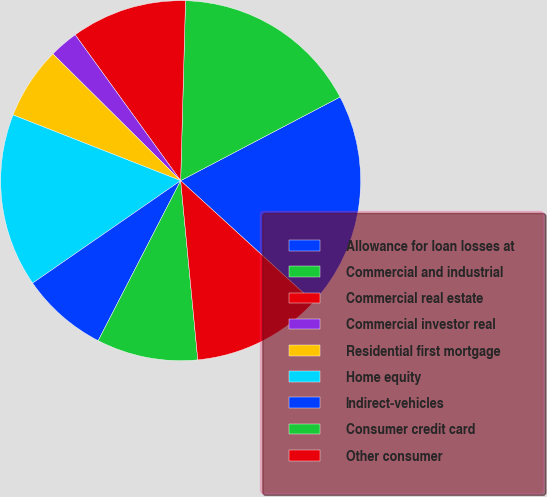Convert chart to OTSL. <chart><loc_0><loc_0><loc_500><loc_500><pie_chart><fcel>Allowance for loan losses at<fcel>Commercial and industrial<fcel>Commercial real estate<fcel>Commercial investor real<fcel>Residential first mortgage<fcel>Home equity<fcel>Indirect-vehicles<fcel>Consumer credit card<fcel>Other consumer<nl><fcel>19.48%<fcel>16.88%<fcel>10.39%<fcel>2.6%<fcel>6.49%<fcel>15.58%<fcel>7.79%<fcel>9.09%<fcel>11.69%<nl></chart> 